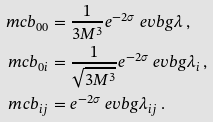Convert formula to latex. <formula><loc_0><loc_0><loc_500><loc_500>\ m c b _ { 0 0 } & = \frac { 1 } { 3 M ^ { 3 } } e ^ { - 2 \sigma } \ e v b g { \lambda } \, , \\ \ m c b _ { 0 i } & = \frac { 1 } { \sqrt { 3 M ^ { 3 } } } e ^ { - 2 \sigma } \ e v b g { \lambda _ { i } } \, , \\ \ m c b _ { i j } & = e ^ { - 2 \sigma } \ e v b g { \lambda _ { i j } } \, .</formula> 